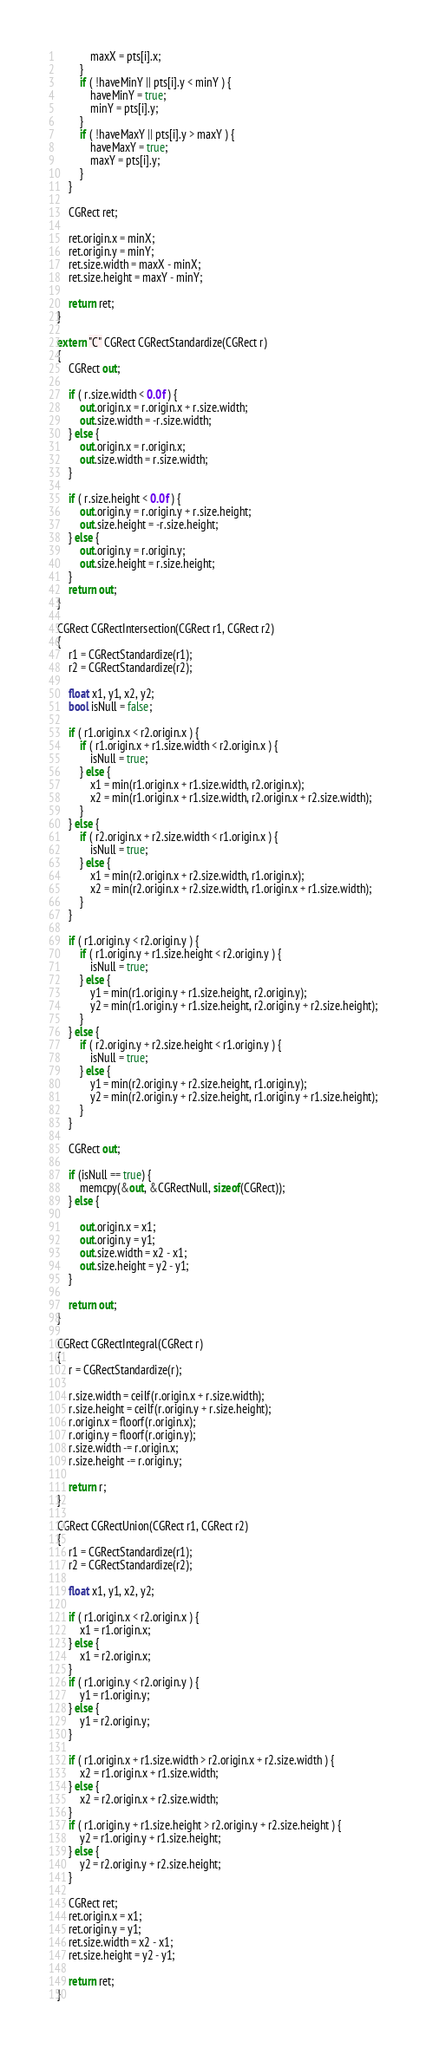Convert code to text. <code><loc_0><loc_0><loc_500><loc_500><_ObjectiveC_>            maxX = pts[i].x;
        }
        if ( !haveMinY || pts[i].y < minY ) {
            haveMinY = true;
            minY = pts[i].y;
        }
        if ( !haveMaxY || pts[i].y > maxY ) {
            haveMaxY = true;
            maxY = pts[i].y;
        }
    }

    CGRect ret;

    ret.origin.x = minX;
    ret.origin.y = minY;
    ret.size.width = maxX - minX;
    ret.size.height = maxY - minY;

    return ret;
}

extern "C" CGRect CGRectStandardize(CGRect r)
{
    CGRect out;

    if ( r.size.width < 0.0f ) {
        out.origin.x = r.origin.x + r.size.width;
        out.size.width = -r.size.width;
    } else {
        out.origin.x = r.origin.x;
        out.size.width = r.size.width;
    }

    if ( r.size.height < 0.0f ) {
        out.origin.y = r.origin.y + r.size.height;
        out.size.height = -r.size.height;
    } else {
        out.origin.y = r.origin.y;
        out.size.height = r.size.height;
    }
    return out;
}

CGRect CGRectIntersection(CGRect r1, CGRect r2)
{
    r1 = CGRectStandardize(r1);
    r2 = CGRectStandardize(r2);

    float x1, y1, x2, y2;
    bool isNull = false;

    if ( r1.origin.x < r2.origin.x ) {
        if ( r1.origin.x + r1.size.width < r2.origin.x ) {
            isNull = true;
        } else {
            x1 = min(r1.origin.x + r1.size.width, r2.origin.x);
            x2 = min(r1.origin.x + r1.size.width, r2.origin.x + r2.size.width);
        }
    } else {
        if ( r2.origin.x + r2.size.width < r1.origin.x ) {
            isNull = true;
        } else {
            x1 = min(r2.origin.x + r2.size.width, r1.origin.x);
            x2 = min(r2.origin.x + r2.size.width, r1.origin.x + r1.size.width);
        }
    }

    if ( r1.origin.y < r2.origin.y ) {
        if ( r1.origin.y + r1.size.height < r2.origin.y ) {
            isNull = true;
        } else {
            y1 = min(r1.origin.y + r1.size.height, r2.origin.y);
            y2 = min(r1.origin.y + r1.size.height, r2.origin.y + r2.size.height);
        }
    } else {
        if ( r2.origin.y + r2.size.height < r1.origin.y ) {
            isNull = true;
        } else {
            y1 = min(r2.origin.y + r2.size.height, r1.origin.y);
            y2 = min(r2.origin.y + r2.size.height, r1.origin.y + r1.size.height);
        }
    }

    CGRect out;

    if (isNull == true) { 
        memcpy(&out, &CGRectNull, sizeof(CGRect));
    } else {

        out.origin.x = x1;
        out.origin.y = y1;
        out.size.width = x2 - x1;
        out.size.height = y2 - y1;
    }

    return out;
}

CGRect CGRectIntegral(CGRect r)
{
    r = CGRectStandardize(r);

    r.size.width = ceilf(r.origin.x + r.size.width);
    r.size.height = ceilf(r.origin.y + r.size.height);
    r.origin.x = floorf(r.origin.x);
    r.origin.y = floorf(r.origin.y);
    r.size.width -= r.origin.x;
    r.size.height -= r.origin.y;

    return r;
}

CGRect CGRectUnion(CGRect r1, CGRect r2)
{
    r1 = CGRectStandardize(r1);
    r2 = CGRectStandardize(r2);

    float x1, y1, x2, y2;

    if ( r1.origin.x < r2.origin.x ) {
        x1 = r1.origin.x;
    } else {
        x1 = r2.origin.x;
    }
    if ( r1.origin.y < r2.origin.y ) {
        y1 = r1.origin.y;
    } else {
        y1 = r2.origin.y;
    }

    if ( r1.origin.x + r1.size.width > r2.origin.x + r2.size.width ) {
        x2 = r1.origin.x + r1.size.width;
    } else {
        x2 = r2.origin.x + r2.size.width;
    }
    if ( r1.origin.y + r1.size.height > r2.origin.y + r2.size.height ) {
        y2 = r1.origin.y + r1.size.height;
    } else {
        y2 = r2.origin.y + r2.size.height;
    }

    CGRect ret;
    ret.origin.x = x1;
    ret.origin.y = y1;
    ret.size.width = x2 - x1;
    ret.size.height = y2 - y1;

    return ret;
}
</code> 